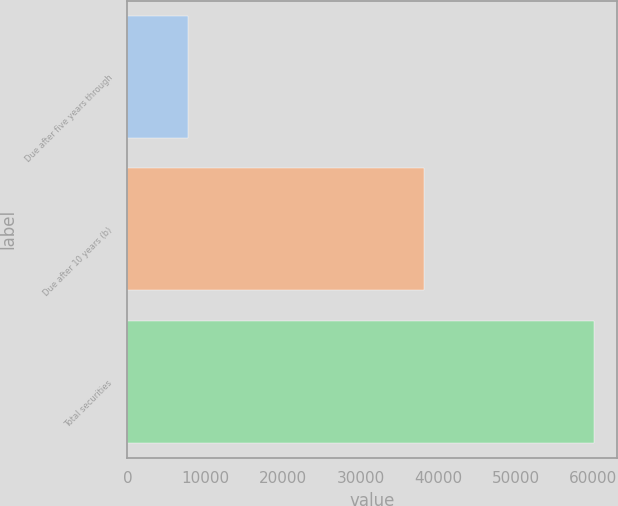Convert chart. <chart><loc_0><loc_0><loc_500><loc_500><bar_chart><fcel>Due after five years through<fcel>Due after 10 years (b)<fcel>Total securities<nl><fcel>7815<fcel>38178<fcel>60068<nl></chart> 